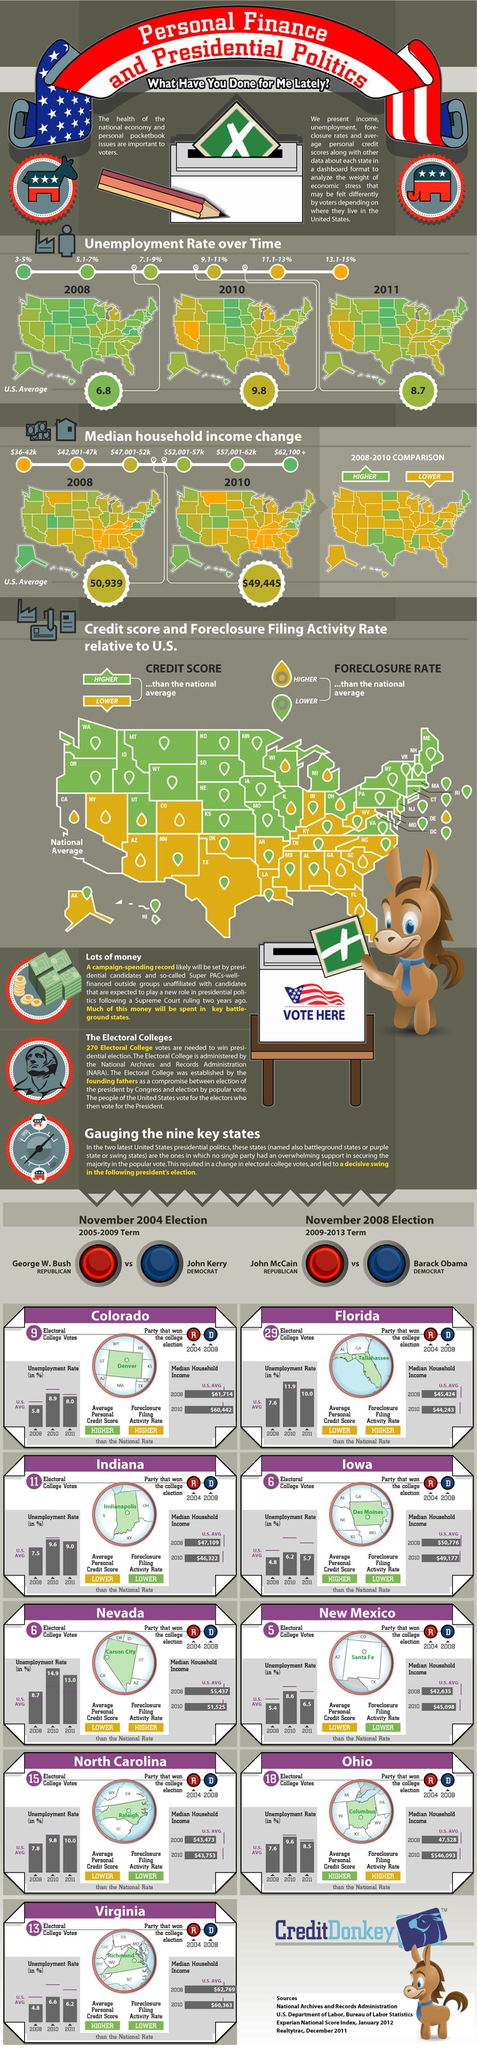Specify some key components in this picture. Four sources are listed at the bottom. 